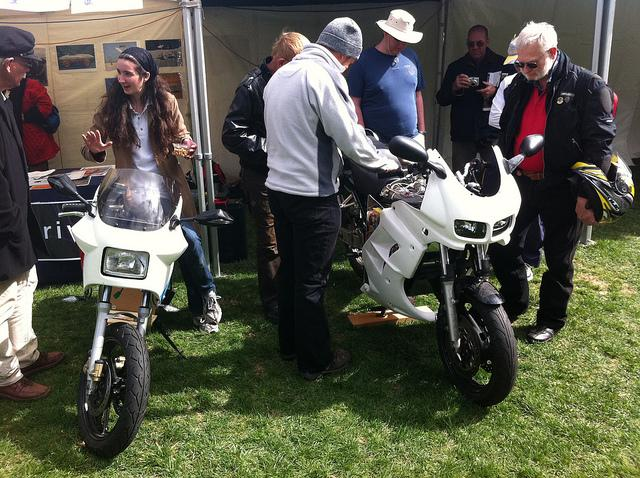What animal is the same color as the bike?

Choices:
A) panther
B) leopard
C) swan
D) giraffe swan 